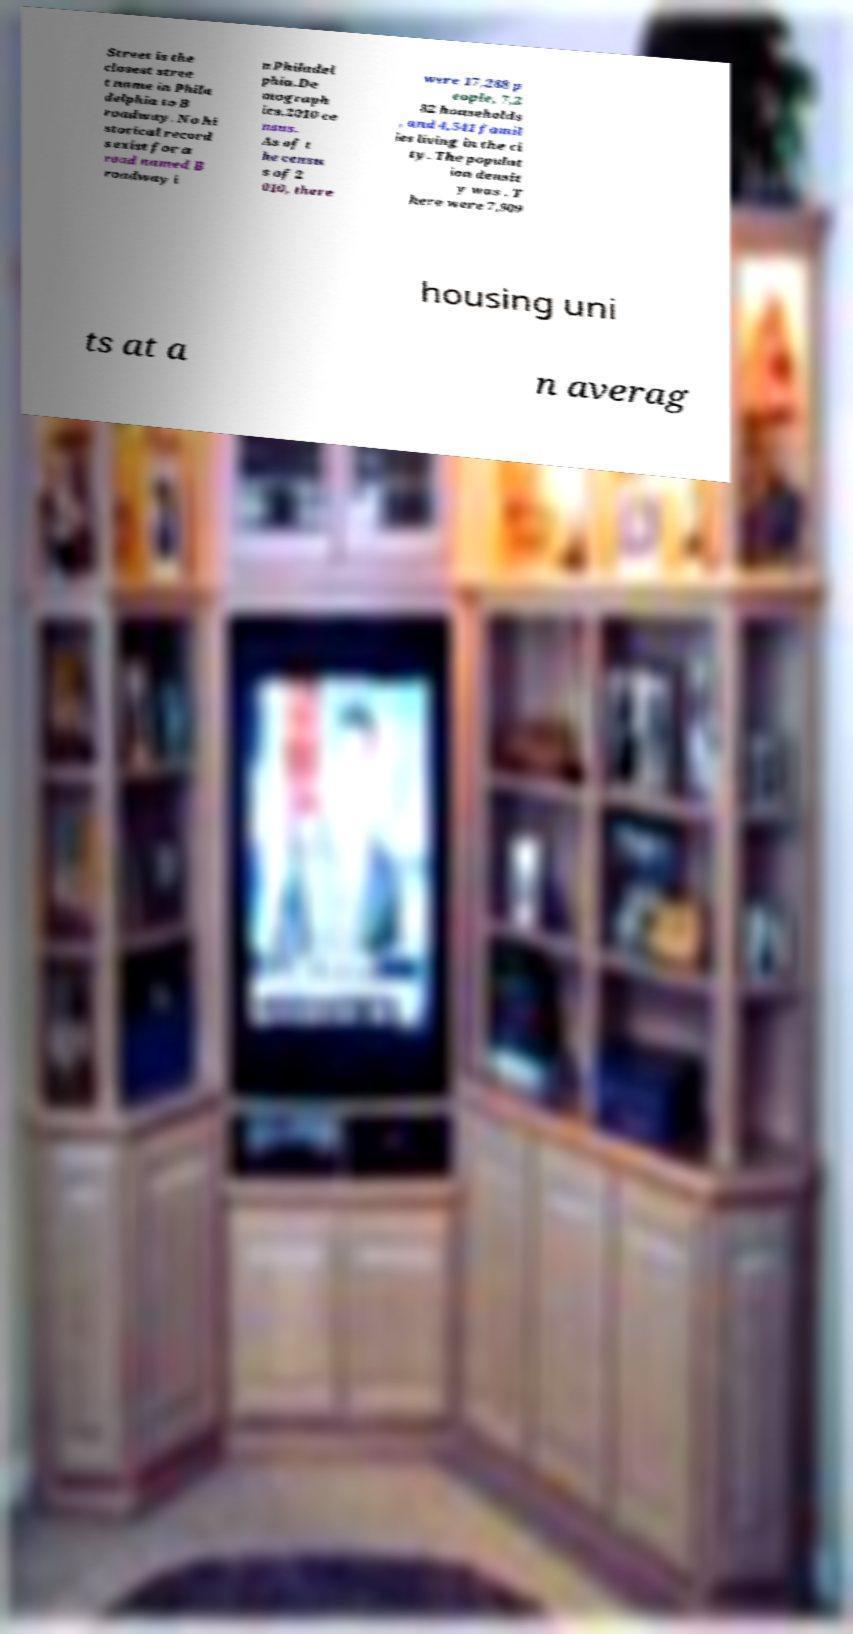What messages or text are displayed in this image? I need them in a readable, typed format. Street is the closest stree t name in Phila delphia to B roadway. No hi storical record s exist for a road named B roadway i n Philadel phia.De mograph ics.2010 ce nsus. As of t he censu s of 2 010, there were 17,288 p eople, 7,2 82 households , and 4,541 famil ies living in the ci ty. The populat ion densit y was . T here were 7,909 housing uni ts at a n averag 